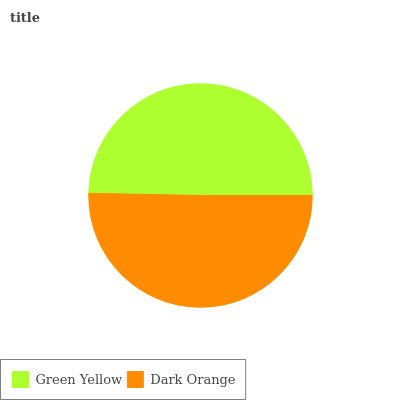Is Green Yellow the minimum?
Answer yes or no. Yes. Is Dark Orange the maximum?
Answer yes or no. Yes. Is Dark Orange the minimum?
Answer yes or no. No. Is Dark Orange greater than Green Yellow?
Answer yes or no. Yes. Is Green Yellow less than Dark Orange?
Answer yes or no. Yes. Is Green Yellow greater than Dark Orange?
Answer yes or no. No. Is Dark Orange less than Green Yellow?
Answer yes or no. No. Is Dark Orange the high median?
Answer yes or no. Yes. Is Green Yellow the low median?
Answer yes or no. Yes. Is Green Yellow the high median?
Answer yes or no. No. Is Dark Orange the low median?
Answer yes or no. No. 